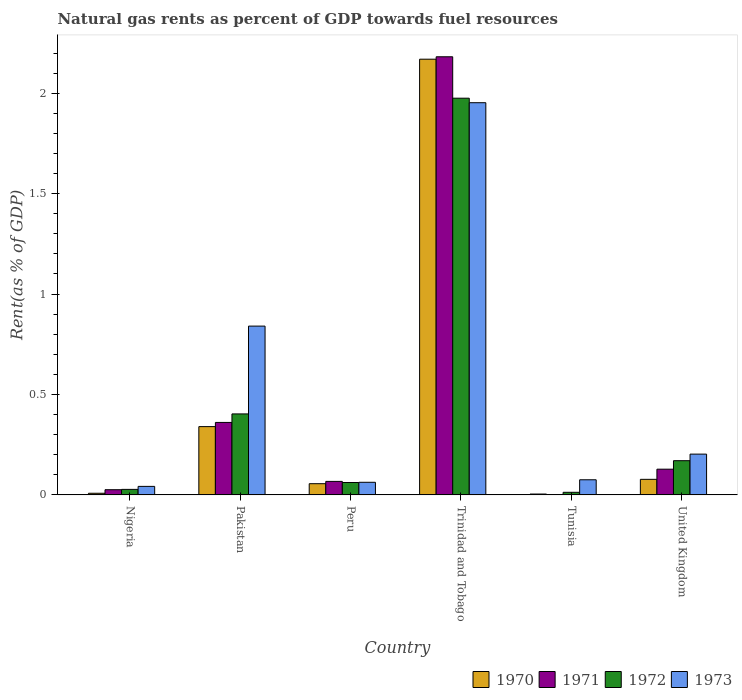How many different coloured bars are there?
Offer a terse response. 4. How many groups of bars are there?
Offer a terse response. 6. Are the number of bars on each tick of the X-axis equal?
Your answer should be very brief. Yes. How many bars are there on the 3rd tick from the right?
Provide a succinct answer. 4. What is the label of the 4th group of bars from the left?
Your answer should be very brief. Trinidad and Tobago. What is the matural gas rent in 1972 in United Kingdom?
Offer a very short reply. 0.17. Across all countries, what is the maximum matural gas rent in 1971?
Offer a terse response. 2.18. Across all countries, what is the minimum matural gas rent in 1971?
Offer a terse response. 0. In which country was the matural gas rent in 1973 maximum?
Offer a terse response. Trinidad and Tobago. In which country was the matural gas rent in 1972 minimum?
Provide a short and direct response. Tunisia. What is the total matural gas rent in 1972 in the graph?
Keep it short and to the point. 2.65. What is the difference between the matural gas rent in 1973 in Nigeria and that in Pakistan?
Your response must be concise. -0.8. What is the difference between the matural gas rent in 1970 in Tunisia and the matural gas rent in 1972 in Pakistan?
Offer a terse response. -0.4. What is the average matural gas rent in 1972 per country?
Your answer should be compact. 0.44. What is the difference between the matural gas rent of/in 1973 and matural gas rent of/in 1970 in Trinidad and Tobago?
Provide a short and direct response. -0.22. In how many countries, is the matural gas rent in 1970 greater than 2 %?
Provide a succinct answer. 1. What is the ratio of the matural gas rent in 1971 in Nigeria to that in Trinidad and Tobago?
Make the answer very short. 0.01. What is the difference between the highest and the second highest matural gas rent in 1971?
Offer a terse response. -1.82. What is the difference between the highest and the lowest matural gas rent in 1973?
Provide a succinct answer. 1.91. Is the sum of the matural gas rent in 1973 in Trinidad and Tobago and Tunisia greater than the maximum matural gas rent in 1971 across all countries?
Offer a terse response. No. Is it the case that in every country, the sum of the matural gas rent in 1971 and matural gas rent in 1973 is greater than the sum of matural gas rent in 1970 and matural gas rent in 1972?
Your response must be concise. No. What does the 2nd bar from the left in Peru represents?
Your answer should be very brief. 1971. Is it the case that in every country, the sum of the matural gas rent in 1971 and matural gas rent in 1973 is greater than the matural gas rent in 1972?
Offer a terse response. Yes. How many bars are there?
Offer a very short reply. 24. How many countries are there in the graph?
Make the answer very short. 6. Are the values on the major ticks of Y-axis written in scientific E-notation?
Your answer should be compact. No. Does the graph contain any zero values?
Provide a succinct answer. No. Does the graph contain grids?
Provide a succinct answer. No. Where does the legend appear in the graph?
Make the answer very short. Bottom right. How many legend labels are there?
Offer a terse response. 4. What is the title of the graph?
Provide a succinct answer. Natural gas rents as percent of GDP towards fuel resources. What is the label or title of the Y-axis?
Your answer should be very brief. Rent(as % of GDP). What is the Rent(as % of GDP) of 1970 in Nigeria?
Offer a terse response. 0.01. What is the Rent(as % of GDP) of 1971 in Nigeria?
Offer a terse response. 0.03. What is the Rent(as % of GDP) in 1972 in Nigeria?
Your answer should be compact. 0.03. What is the Rent(as % of GDP) in 1973 in Nigeria?
Offer a very short reply. 0.04. What is the Rent(as % of GDP) of 1970 in Pakistan?
Provide a succinct answer. 0.34. What is the Rent(as % of GDP) in 1971 in Pakistan?
Offer a very short reply. 0.36. What is the Rent(as % of GDP) in 1972 in Pakistan?
Your response must be concise. 0.4. What is the Rent(as % of GDP) in 1973 in Pakistan?
Provide a succinct answer. 0.84. What is the Rent(as % of GDP) of 1970 in Peru?
Offer a terse response. 0.06. What is the Rent(as % of GDP) of 1971 in Peru?
Offer a terse response. 0.07. What is the Rent(as % of GDP) in 1972 in Peru?
Your answer should be compact. 0.06. What is the Rent(as % of GDP) of 1973 in Peru?
Ensure brevity in your answer.  0.06. What is the Rent(as % of GDP) in 1970 in Trinidad and Tobago?
Offer a very short reply. 2.17. What is the Rent(as % of GDP) in 1971 in Trinidad and Tobago?
Make the answer very short. 2.18. What is the Rent(as % of GDP) of 1972 in Trinidad and Tobago?
Your answer should be compact. 1.98. What is the Rent(as % of GDP) in 1973 in Trinidad and Tobago?
Offer a terse response. 1.95. What is the Rent(as % of GDP) of 1970 in Tunisia?
Offer a very short reply. 0. What is the Rent(as % of GDP) in 1971 in Tunisia?
Your response must be concise. 0. What is the Rent(as % of GDP) of 1972 in Tunisia?
Keep it short and to the point. 0.01. What is the Rent(as % of GDP) in 1973 in Tunisia?
Ensure brevity in your answer.  0.08. What is the Rent(as % of GDP) in 1970 in United Kingdom?
Offer a very short reply. 0.08. What is the Rent(as % of GDP) in 1971 in United Kingdom?
Ensure brevity in your answer.  0.13. What is the Rent(as % of GDP) in 1972 in United Kingdom?
Offer a terse response. 0.17. What is the Rent(as % of GDP) in 1973 in United Kingdom?
Provide a succinct answer. 0.2. Across all countries, what is the maximum Rent(as % of GDP) of 1970?
Make the answer very short. 2.17. Across all countries, what is the maximum Rent(as % of GDP) in 1971?
Offer a terse response. 2.18. Across all countries, what is the maximum Rent(as % of GDP) in 1972?
Provide a short and direct response. 1.98. Across all countries, what is the maximum Rent(as % of GDP) of 1973?
Give a very brief answer. 1.95. Across all countries, what is the minimum Rent(as % of GDP) of 1970?
Provide a short and direct response. 0. Across all countries, what is the minimum Rent(as % of GDP) of 1971?
Your answer should be compact. 0. Across all countries, what is the minimum Rent(as % of GDP) in 1972?
Offer a terse response. 0.01. Across all countries, what is the minimum Rent(as % of GDP) of 1973?
Provide a short and direct response. 0.04. What is the total Rent(as % of GDP) in 1970 in the graph?
Your answer should be very brief. 2.65. What is the total Rent(as % of GDP) in 1971 in the graph?
Make the answer very short. 2.76. What is the total Rent(as % of GDP) in 1972 in the graph?
Your answer should be compact. 2.65. What is the total Rent(as % of GDP) in 1973 in the graph?
Make the answer very short. 3.18. What is the difference between the Rent(as % of GDP) in 1970 in Nigeria and that in Pakistan?
Your response must be concise. -0.33. What is the difference between the Rent(as % of GDP) of 1971 in Nigeria and that in Pakistan?
Offer a very short reply. -0.34. What is the difference between the Rent(as % of GDP) in 1972 in Nigeria and that in Pakistan?
Ensure brevity in your answer.  -0.38. What is the difference between the Rent(as % of GDP) in 1973 in Nigeria and that in Pakistan?
Your answer should be very brief. -0.8. What is the difference between the Rent(as % of GDP) in 1970 in Nigeria and that in Peru?
Provide a succinct answer. -0.05. What is the difference between the Rent(as % of GDP) of 1971 in Nigeria and that in Peru?
Ensure brevity in your answer.  -0.04. What is the difference between the Rent(as % of GDP) of 1972 in Nigeria and that in Peru?
Provide a succinct answer. -0.03. What is the difference between the Rent(as % of GDP) in 1973 in Nigeria and that in Peru?
Your answer should be compact. -0.02. What is the difference between the Rent(as % of GDP) of 1970 in Nigeria and that in Trinidad and Tobago?
Your answer should be very brief. -2.16. What is the difference between the Rent(as % of GDP) in 1971 in Nigeria and that in Trinidad and Tobago?
Ensure brevity in your answer.  -2.16. What is the difference between the Rent(as % of GDP) of 1972 in Nigeria and that in Trinidad and Tobago?
Offer a terse response. -1.95. What is the difference between the Rent(as % of GDP) of 1973 in Nigeria and that in Trinidad and Tobago?
Provide a short and direct response. -1.91. What is the difference between the Rent(as % of GDP) of 1970 in Nigeria and that in Tunisia?
Give a very brief answer. 0. What is the difference between the Rent(as % of GDP) in 1971 in Nigeria and that in Tunisia?
Ensure brevity in your answer.  0.03. What is the difference between the Rent(as % of GDP) in 1972 in Nigeria and that in Tunisia?
Offer a very short reply. 0.01. What is the difference between the Rent(as % of GDP) in 1973 in Nigeria and that in Tunisia?
Give a very brief answer. -0.03. What is the difference between the Rent(as % of GDP) in 1970 in Nigeria and that in United Kingdom?
Your answer should be very brief. -0.07. What is the difference between the Rent(as % of GDP) of 1971 in Nigeria and that in United Kingdom?
Your answer should be compact. -0.1. What is the difference between the Rent(as % of GDP) of 1972 in Nigeria and that in United Kingdom?
Give a very brief answer. -0.14. What is the difference between the Rent(as % of GDP) of 1973 in Nigeria and that in United Kingdom?
Provide a short and direct response. -0.16. What is the difference between the Rent(as % of GDP) of 1970 in Pakistan and that in Peru?
Give a very brief answer. 0.28. What is the difference between the Rent(as % of GDP) in 1971 in Pakistan and that in Peru?
Ensure brevity in your answer.  0.29. What is the difference between the Rent(as % of GDP) of 1972 in Pakistan and that in Peru?
Provide a short and direct response. 0.34. What is the difference between the Rent(as % of GDP) of 1973 in Pakistan and that in Peru?
Ensure brevity in your answer.  0.78. What is the difference between the Rent(as % of GDP) in 1970 in Pakistan and that in Trinidad and Tobago?
Your answer should be very brief. -1.83. What is the difference between the Rent(as % of GDP) in 1971 in Pakistan and that in Trinidad and Tobago?
Give a very brief answer. -1.82. What is the difference between the Rent(as % of GDP) in 1972 in Pakistan and that in Trinidad and Tobago?
Make the answer very short. -1.57. What is the difference between the Rent(as % of GDP) of 1973 in Pakistan and that in Trinidad and Tobago?
Your response must be concise. -1.11. What is the difference between the Rent(as % of GDP) of 1970 in Pakistan and that in Tunisia?
Offer a terse response. 0.34. What is the difference between the Rent(as % of GDP) of 1971 in Pakistan and that in Tunisia?
Provide a succinct answer. 0.36. What is the difference between the Rent(as % of GDP) of 1972 in Pakistan and that in Tunisia?
Offer a very short reply. 0.39. What is the difference between the Rent(as % of GDP) of 1973 in Pakistan and that in Tunisia?
Ensure brevity in your answer.  0.77. What is the difference between the Rent(as % of GDP) in 1970 in Pakistan and that in United Kingdom?
Ensure brevity in your answer.  0.26. What is the difference between the Rent(as % of GDP) of 1971 in Pakistan and that in United Kingdom?
Make the answer very short. 0.23. What is the difference between the Rent(as % of GDP) in 1972 in Pakistan and that in United Kingdom?
Your answer should be compact. 0.23. What is the difference between the Rent(as % of GDP) of 1973 in Pakistan and that in United Kingdom?
Provide a short and direct response. 0.64. What is the difference between the Rent(as % of GDP) of 1970 in Peru and that in Trinidad and Tobago?
Keep it short and to the point. -2.11. What is the difference between the Rent(as % of GDP) in 1971 in Peru and that in Trinidad and Tobago?
Your answer should be very brief. -2.11. What is the difference between the Rent(as % of GDP) in 1972 in Peru and that in Trinidad and Tobago?
Provide a succinct answer. -1.91. What is the difference between the Rent(as % of GDP) of 1973 in Peru and that in Trinidad and Tobago?
Give a very brief answer. -1.89. What is the difference between the Rent(as % of GDP) in 1970 in Peru and that in Tunisia?
Offer a terse response. 0.05. What is the difference between the Rent(as % of GDP) in 1971 in Peru and that in Tunisia?
Your answer should be compact. 0.07. What is the difference between the Rent(as % of GDP) in 1972 in Peru and that in Tunisia?
Keep it short and to the point. 0.05. What is the difference between the Rent(as % of GDP) of 1973 in Peru and that in Tunisia?
Your answer should be compact. -0.01. What is the difference between the Rent(as % of GDP) in 1970 in Peru and that in United Kingdom?
Provide a succinct answer. -0.02. What is the difference between the Rent(as % of GDP) of 1971 in Peru and that in United Kingdom?
Your response must be concise. -0.06. What is the difference between the Rent(as % of GDP) of 1972 in Peru and that in United Kingdom?
Give a very brief answer. -0.11. What is the difference between the Rent(as % of GDP) in 1973 in Peru and that in United Kingdom?
Provide a short and direct response. -0.14. What is the difference between the Rent(as % of GDP) of 1970 in Trinidad and Tobago and that in Tunisia?
Provide a short and direct response. 2.17. What is the difference between the Rent(as % of GDP) in 1971 in Trinidad and Tobago and that in Tunisia?
Ensure brevity in your answer.  2.18. What is the difference between the Rent(as % of GDP) in 1972 in Trinidad and Tobago and that in Tunisia?
Give a very brief answer. 1.96. What is the difference between the Rent(as % of GDP) in 1973 in Trinidad and Tobago and that in Tunisia?
Ensure brevity in your answer.  1.88. What is the difference between the Rent(as % of GDP) in 1970 in Trinidad and Tobago and that in United Kingdom?
Make the answer very short. 2.09. What is the difference between the Rent(as % of GDP) in 1971 in Trinidad and Tobago and that in United Kingdom?
Give a very brief answer. 2.05. What is the difference between the Rent(as % of GDP) in 1972 in Trinidad and Tobago and that in United Kingdom?
Your answer should be compact. 1.8. What is the difference between the Rent(as % of GDP) of 1973 in Trinidad and Tobago and that in United Kingdom?
Your answer should be compact. 1.75. What is the difference between the Rent(as % of GDP) of 1970 in Tunisia and that in United Kingdom?
Your answer should be very brief. -0.07. What is the difference between the Rent(as % of GDP) of 1971 in Tunisia and that in United Kingdom?
Your answer should be very brief. -0.13. What is the difference between the Rent(as % of GDP) of 1972 in Tunisia and that in United Kingdom?
Provide a succinct answer. -0.16. What is the difference between the Rent(as % of GDP) in 1973 in Tunisia and that in United Kingdom?
Provide a short and direct response. -0.13. What is the difference between the Rent(as % of GDP) in 1970 in Nigeria and the Rent(as % of GDP) in 1971 in Pakistan?
Offer a very short reply. -0.35. What is the difference between the Rent(as % of GDP) of 1970 in Nigeria and the Rent(as % of GDP) of 1972 in Pakistan?
Make the answer very short. -0.4. What is the difference between the Rent(as % of GDP) in 1970 in Nigeria and the Rent(as % of GDP) in 1973 in Pakistan?
Offer a very short reply. -0.83. What is the difference between the Rent(as % of GDP) of 1971 in Nigeria and the Rent(as % of GDP) of 1972 in Pakistan?
Keep it short and to the point. -0.38. What is the difference between the Rent(as % of GDP) in 1971 in Nigeria and the Rent(as % of GDP) in 1973 in Pakistan?
Ensure brevity in your answer.  -0.81. What is the difference between the Rent(as % of GDP) of 1972 in Nigeria and the Rent(as % of GDP) of 1973 in Pakistan?
Your answer should be compact. -0.81. What is the difference between the Rent(as % of GDP) of 1970 in Nigeria and the Rent(as % of GDP) of 1971 in Peru?
Offer a very short reply. -0.06. What is the difference between the Rent(as % of GDP) of 1970 in Nigeria and the Rent(as % of GDP) of 1972 in Peru?
Give a very brief answer. -0.05. What is the difference between the Rent(as % of GDP) of 1970 in Nigeria and the Rent(as % of GDP) of 1973 in Peru?
Provide a short and direct response. -0.05. What is the difference between the Rent(as % of GDP) in 1971 in Nigeria and the Rent(as % of GDP) in 1972 in Peru?
Provide a short and direct response. -0.04. What is the difference between the Rent(as % of GDP) of 1971 in Nigeria and the Rent(as % of GDP) of 1973 in Peru?
Keep it short and to the point. -0.04. What is the difference between the Rent(as % of GDP) in 1972 in Nigeria and the Rent(as % of GDP) in 1973 in Peru?
Provide a succinct answer. -0.04. What is the difference between the Rent(as % of GDP) of 1970 in Nigeria and the Rent(as % of GDP) of 1971 in Trinidad and Tobago?
Give a very brief answer. -2.17. What is the difference between the Rent(as % of GDP) in 1970 in Nigeria and the Rent(as % of GDP) in 1972 in Trinidad and Tobago?
Offer a terse response. -1.97. What is the difference between the Rent(as % of GDP) in 1970 in Nigeria and the Rent(as % of GDP) in 1973 in Trinidad and Tobago?
Provide a succinct answer. -1.94. What is the difference between the Rent(as % of GDP) of 1971 in Nigeria and the Rent(as % of GDP) of 1972 in Trinidad and Tobago?
Make the answer very short. -1.95. What is the difference between the Rent(as % of GDP) of 1971 in Nigeria and the Rent(as % of GDP) of 1973 in Trinidad and Tobago?
Keep it short and to the point. -1.93. What is the difference between the Rent(as % of GDP) of 1972 in Nigeria and the Rent(as % of GDP) of 1973 in Trinidad and Tobago?
Keep it short and to the point. -1.93. What is the difference between the Rent(as % of GDP) of 1970 in Nigeria and the Rent(as % of GDP) of 1971 in Tunisia?
Provide a short and direct response. 0.01. What is the difference between the Rent(as % of GDP) of 1970 in Nigeria and the Rent(as % of GDP) of 1972 in Tunisia?
Your response must be concise. -0. What is the difference between the Rent(as % of GDP) in 1970 in Nigeria and the Rent(as % of GDP) in 1973 in Tunisia?
Your answer should be very brief. -0.07. What is the difference between the Rent(as % of GDP) of 1971 in Nigeria and the Rent(as % of GDP) of 1972 in Tunisia?
Provide a succinct answer. 0.01. What is the difference between the Rent(as % of GDP) in 1971 in Nigeria and the Rent(as % of GDP) in 1973 in Tunisia?
Offer a very short reply. -0.05. What is the difference between the Rent(as % of GDP) of 1972 in Nigeria and the Rent(as % of GDP) of 1973 in Tunisia?
Provide a short and direct response. -0.05. What is the difference between the Rent(as % of GDP) in 1970 in Nigeria and the Rent(as % of GDP) in 1971 in United Kingdom?
Provide a succinct answer. -0.12. What is the difference between the Rent(as % of GDP) in 1970 in Nigeria and the Rent(as % of GDP) in 1972 in United Kingdom?
Give a very brief answer. -0.16. What is the difference between the Rent(as % of GDP) in 1970 in Nigeria and the Rent(as % of GDP) in 1973 in United Kingdom?
Your response must be concise. -0.19. What is the difference between the Rent(as % of GDP) of 1971 in Nigeria and the Rent(as % of GDP) of 1972 in United Kingdom?
Make the answer very short. -0.14. What is the difference between the Rent(as % of GDP) of 1971 in Nigeria and the Rent(as % of GDP) of 1973 in United Kingdom?
Offer a terse response. -0.18. What is the difference between the Rent(as % of GDP) in 1972 in Nigeria and the Rent(as % of GDP) in 1973 in United Kingdom?
Offer a terse response. -0.18. What is the difference between the Rent(as % of GDP) of 1970 in Pakistan and the Rent(as % of GDP) of 1971 in Peru?
Offer a terse response. 0.27. What is the difference between the Rent(as % of GDP) in 1970 in Pakistan and the Rent(as % of GDP) in 1972 in Peru?
Make the answer very short. 0.28. What is the difference between the Rent(as % of GDP) in 1970 in Pakistan and the Rent(as % of GDP) in 1973 in Peru?
Offer a terse response. 0.28. What is the difference between the Rent(as % of GDP) of 1971 in Pakistan and the Rent(as % of GDP) of 1972 in Peru?
Give a very brief answer. 0.3. What is the difference between the Rent(as % of GDP) in 1971 in Pakistan and the Rent(as % of GDP) in 1973 in Peru?
Provide a succinct answer. 0.3. What is the difference between the Rent(as % of GDP) in 1972 in Pakistan and the Rent(as % of GDP) in 1973 in Peru?
Offer a very short reply. 0.34. What is the difference between the Rent(as % of GDP) of 1970 in Pakistan and the Rent(as % of GDP) of 1971 in Trinidad and Tobago?
Keep it short and to the point. -1.84. What is the difference between the Rent(as % of GDP) in 1970 in Pakistan and the Rent(as % of GDP) in 1972 in Trinidad and Tobago?
Offer a terse response. -1.64. What is the difference between the Rent(as % of GDP) in 1970 in Pakistan and the Rent(as % of GDP) in 1973 in Trinidad and Tobago?
Your answer should be very brief. -1.61. What is the difference between the Rent(as % of GDP) in 1971 in Pakistan and the Rent(as % of GDP) in 1972 in Trinidad and Tobago?
Make the answer very short. -1.61. What is the difference between the Rent(as % of GDP) in 1971 in Pakistan and the Rent(as % of GDP) in 1973 in Trinidad and Tobago?
Your answer should be very brief. -1.59. What is the difference between the Rent(as % of GDP) in 1972 in Pakistan and the Rent(as % of GDP) in 1973 in Trinidad and Tobago?
Your response must be concise. -1.55. What is the difference between the Rent(as % of GDP) in 1970 in Pakistan and the Rent(as % of GDP) in 1971 in Tunisia?
Make the answer very short. 0.34. What is the difference between the Rent(as % of GDP) of 1970 in Pakistan and the Rent(as % of GDP) of 1972 in Tunisia?
Your response must be concise. 0.33. What is the difference between the Rent(as % of GDP) in 1970 in Pakistan and the Rent(as % of GDP) in 1973 in Tunisia?
Make the answer very short. 0.26. What is the difference between the Rent(as % of GDP) of 1971 in Pakistan and the Rent(as % of GDP) of 1972 in Tunisia?
Make the answer very short. 0.35. What is the difference between the Rent(as % of GDP) in 1971 in Pakistan and the Rent(as % of GDP) in 1973 in Tunisia?
Your response must be concise. 0.29. What is the difference between the Rent(as % of GDP) of 1972 in Pakistan and the Rent(as % of GDP) of 1973 in Tunisia?
Offer a very short reply. 0.33. What is the difference between the Rent(as % of GDP) in 1970 in Pakistan and the Rent(as % of GDP) in 1971 in United Kingdom?
Make the answer very short. 0.21. What is the difference between the Rent(as % of GDP) of 1970 in Pakistan and the Rent(as % of GDP) of 1972 in United Kingdom?
Provide a short and direct response. 0.17. What is the difference between the Rent(as % of GDP) of 1970 in Pakistan and the Rent(as % of GDP) of 1973 in United Kingdom?
Make the answer very short. 0.14. What is the difference between the Rent(as % of GDP) of 1971 in Pakistan and the Rent(as % of GDP) of 1972 in United Kingdom?
Give a very brief answer. 0.19. What is the difference between the Rent(as % of GDP) in 1971 in Pakistan and the Rent(as % of GDP) in 1973 in United Kingdom?
Offer a terse response. 0.16. What is the difference between the Rent(as % of GDP) in 1972 in Pakistan and the Rent(as % of GDP) in 1973 in United Kingdom?
Offer a very short reply. 0.2. What is the difference between the Rent(as % of GDP) of 1970 in Peru and the Rent(as % of GDP) of 1971 in Trinidad and Tobago?
Ensure brevity in your answer.  -2.13. What is the difference between the Rent(as % of GDP) of 1970 in Peru and the Rent(as % of GDP) of 1972 in Trinidad and Tobago?
Provide a succinct answer. -1.92. What is the difference between the Rent(as % of GDP) in 1970 in Peru and the Rent(as % of GDP) in 1973 in Trinidad and Tobago?
Your answer should be compact. -1.9. What is the difference between the Rent(as % of GDP) of 1971 in Peru and the Rent(as % of GDP) of 1972 in Trinidad and Tobago?
Keep it short and to the point. -1.91. What is the difference between the Rent(as % of GDP) of 1971 in Peru and the Rent(as % of GDP) of 1973 in Trinidad and Tobago?
Give a very brief answer. -1.89. What is the difference between the Rent(as % of GDP) in 1972 in Peru and the Rent(as % of GDP) in 1973 in Trinidad and Tobago?
Make the answer very short. -1.89. What is the difference between the Rent(as % of GDP) of 1970 in Peru and the Rent(as % of GDP) of 1971 in Tunisia?
Provide a succinct answer. 0.06. What is the difference between the Rent(as % of GDP) in 1970 in Peru and the Rent(as % of GDP) in 1972 in Tunisia?
Offer a very short reply. 0.04. What is the difference between the Rent(as % of GDP) in 1970 in Peru and the Rent(as % of GDP) in 1973 in Tunisia?
Your response must be concise. -0.02. What is the difference between the Rent(as % of GDP) of 1971 in Peru and the Rent(as % of GDP) of 1972 in Tunisia?
Make the answer very short. 0.05. What is the difference between the Rent(as % of GDP) of 1971 in Peru and the Rent(as % of GDP) of 1973 in Tunisia?
Provide a succinct answer. -0.01. What is the difference between the Rent(as % of GDP) in 1972 in Peru and the Rent(as % of GDP) in 1973 in Tunisia?
Your answer should be very brief. -0.01. What is the difference between the Rent(as % of GDP) of 1970 in Peru and the Rent(as % of GDP) of 1971 in United Kingdom?
Keep it short and to the point. -0.07. What is the difference between the Rent(as % of GDP) of 1970 in Peru and the Rent(as % of GDP) of 1972 in United Kingdom?
Ensure brevity in your answer.  -0.11. What is the difference between the Rent(as % of GDP) in 1970 in Peru and the Rent(as % of GDP) in 1973 in United Kingdom?
Ensure brevity in your answer.  -0.15. What is the difference between the Rent(as % of GDP) of 1971 in Peru and the Rent(as % of GDP) of 1972 in United Kingdom?
Provide a short and direct response. -0.1. What is the difference between the Rent(as % of GDP) of 1971 in Peru and the Rent(as % of GDP) of 1973 in United Kingdom?
Give a very brief answer. -0.14. What is the difference between the Rent(as % of GDP) of 1972 in Peru and the Rent(as % of GDP) of 1973 in United Kingdom?
Give a very brief answer. -0.14. What is the difference between the Rent(as % of GDP) of 1970 in Trinidad and Tobago and the Rent(as % of GDP) of 1971 in Tunisia?
Your response must be concise. 2.17. What is the difference between the Rent(as % of GDP) in 1970 in Trinidad and Tobago and the Rent(as % of GDP) in 1972 in Tunisia?
Your answer should be very brief. 2.16. What is the difference between the Rent(as % of GDP) in 1970 in Trinidad and Tobago and the Rent(as % of GDP) in 1973 in Tunisia?
Provide a short and direct response. 2.09. What is the difference between the Rent(as % of GDP) of 1971 in Trinidad and Tobago and the Rent(as % of GDP) of 1972 in Tunisia?
Your response must be concise. 2.17. What is the difference between the Rent(as % of GDP) in 1971 in Trinidad and Tobago and the Rent(as % of GDP) in 1973 in Tunisia?
Make the answer very short. 2.11. What is the difference between the Rent(as % of GDP) of 1972 in Trinidad and Tobago and the Rent(as % of GDP) of 1973 in Tunisia?
Provide a succinct answer. 1.9. What is the difference between the Rent(as % of GDP) of 1970 in Trinidad and Tobago and the Rent(as % of GDP) of 1971 in United Kingdom?
Your answer should be compact. 2.04. What is the difference between the Rent(as % of GDP) in 1970 in Trinidad and Tobago and the Rent(as % of GDP) in 1972 in United Kingdom?
Provide a succinct answer. 2. What is the difference between the Rent(as % of GDP) in 1970 in Trinidad and Tobago and the Rent(as % of GDP) in 1973 in United Kingdom?
Your answer should be very brief. 1.97. What is the difference between the Rent(as % of GDP) in 1971 in Trinidad and Tobago and the Rent(as % of GDP) in 1972 in United Kingdom?
Offer a very short reply. 2.01. What is the difference between the Rent(as % of GDP) of 1971 in Trinidad and Tobago and the Rent(as % of GDP) of 1973 in United Kingdom?
Give a very brief answer. 1.98. What is the difference between the Rent(as % of GDP) of 1972 in Trinidad and Tobago and the Rent(as % of GDP) of 1973 in United Kingdom?
Your answer should be very brief. 1.77. What is the difference between the Rent(as % of GDP) in 1970 in Tunisia and the Rent(as % of GDP) in 1971 in United Kingdom?
Your response must be concise. -0.12. What is the difference between the Rent(as % of GDP) in 1970 in Tunisia and the Rent(as % of GDP) in 1972 in United Kingdom?
Provide a short and direct response. -0.17. What is the difference between the Rent(as % of GDP) in 1970 in Tunisia and the Rent(as % of GDP) in 1973 in United Kingdom?
Your answer should be very brief. -0.2. What is the difference between the Rent(as % of GDP) of 1971 in Tunisia and the Rent(as % of GDP) of 1972 in United Kingdom?
Offer a very short reply. -0.17. What is the difference between the Rent(as % of GDP) in 1971 in Tunisia and the Rent(as % of GDP) in 1973 in United Kingdom?
Offer a very short reply. -0.2. What is the difference between the Rent(as % of GDP) of 1972 in Tunisia and the Rent(as % of GDP) of 1973 in United Kingdom?
Offer a terse response. -0.19. What is the average Rent(as % of GDP) in 1970 per country?
Provide a succinct answer. 0.44. What is the average Rent(as % of GDP) of 1971 per country?
Ensure brevity in your answer.  0.46. What is the average Rent(as % of GDP) of 1972 per country?
Keep it short and to the point. 0.44. What is the average Rent(as % of GDP) in 1973 per country?
Make the answer very short. 0.53. What is the difference between the Rent(as % of GDP) in 1970 and Rent(as % of GDP) in 1971 in Nigeria?
Provide a succinct answer. -0.02. What is the difference between the Rent(as % of GDP) of 1970 and Rent(as % of GDP) of 1972 in Nigeria?
Offer a very short reply. -0.02. What is the difference between the Rent(as % of GDP) in 1970 and Rent(as % of GDP) in 1973 in Nigeria?
Give a very brief answer. -0.03. What is the difference between the Rent(as % of GDP) in 1971 and Rent(as % of GDP) in 1972 in Nigeria?
Your answer should be compact. -0. What is the difference between the Rent(as % of GDP) of 1971 and Rent(as % of GDP) of 1973 in Nigeria?
Ensure brevity in your answer.  -0.02. What is the difference between the Rent(as % of GDP) of 1972 and Rent(as % of GDP) of 1973 in Nigeria?
Ensure brevity in your answer.  -0.01. What is the difference between the Rent(as % of GDP) of 1970 and Rent(as % of GDP) of 1971 in Pakistan?
Ensure brevity in your answer.  -0.02. What is the difference between the Rent(as % of GDP) of 1970 and Rent(as % of GDP) of 1972 in Pakistan?
Your answer should be very brief. -0.06. What is the difference between the Rent(as % of GDP) in 1970 and Rent(as % of GDP) in 1973 in Pakistan?
Offer a very short reply. -0.5. What is the difference between the Rent(as % of GDP) in 1971 and Rent(as % of GDP) in 1972 in Pakistan?
Your answer should be very brief. -0.04. What is the difference between the Rent(as % of GDP) in 1971 and Rent(as % of GDP) in 1973 in Pakistan?
Your answer should be compact. -0.48. What is the difference between the Rent(as % of GDP) in 1972 and Rent(as % of GDP) in 1973 in Pakistan?
Offer a terse response. -0.44. What is the difference between the Rent(as % of GDP) in 1970 and Rent(as % of GDP) in 1971 in Peru?
Your answer should be very brief. -0.01. What is the difference between the Rent(as % of GDP) in 1970 and Rent(as % of GDP) in 1972 in Peru?
Offer a terse response. -0.01. What is the difference between the Rent(as % of GDP) in 1970 and Rent(as % of GDP) in 1973 in Peru?
Offer a very short reply. -0.01. What is the difference between the Rent(as % of GDP) of 1971 and Rent(as % of GDP) of 1972 in Peru?
Provide a short and direct response. 0.01. What is the difference between the Rent(as % of GDP) in 1971 and Rent(as % of GDP) in 1973 in Peru?
Offer a terse response. 0. What is the difference between the Rent(as % of GDP) of 1972 and Rent(as % of GDP) of 1973 in Peru?
Your answer should be compact. -0. What is the difference between the Rent(as % of GDP) in 1970 and Rent(as % of GDP) in 1971 in Trinidad and Tobago?
Provide a short and direct response. -0.01. What is the difference between the Rent(as % of GDP) in 1970 and Rent(as % of GDP) in 1972 in Trinidad and Tobago?
Your answer should be very brief. 0.19. What is the difference between the Rent(as % of GDP) in 1970 and Rent(as % of GDP) in 1973 in Trinidad and Tobago?
Provide a short and direct response. 0.22. What is the difference between the Rent(as % of GDP) in 1971 and Rent(as % of GDP) in 1972 in Trinidad and Tobago?
Offer a very short reply. 0.21. What is the difference between the Rent(as % of GDP) of 1971 and Rent(as % of GDP) of 1973 in Trinidad and Tobago?
Your answer should be very brief. 0.23. What is the difference between the Rent(as % of GDP) of 1972 and Rent(as % of GDP) of 1973 in Trinidad and Tobago?
Offer a terse response. 0.02. What is the difference between the Rent(as % of GDP) of 1970 and Rent(as % of GDP) of 1971 in Tunisia?
Give a very brief answer. 0. What is the difference between the Rent(as % of GDP) of 1970 and Rent(as % of GDP) of 1972 in Tunisia?
Offer a terse response. -0.01. What is the difference between the Rent(as % of GDP) of 1970 and Rent(as % of GDP) of 1973 in Tunisia?
Offer a very short reply. -0.07. What is the difference between the Rent(as % of GDP) in 1971 and Rent(as % of GDP) in 1972 in Tunisia?
Keep it short and to the point. -0.01. What is the difference between the Rent(as % of GDP) of 1971 and Rent(as % of GDP) of 1973 in Tunisia?
Your answer should be compact. -0.07. What is the difference between the Rent(as % of GDP) of 1972 and Rent(as % of GDP) of 1973 in Tunisia?
Make the answer very short. -0.06. What is the difference between the Rent(as % of GDP) of 1970 and Rent(as % of GDP) of 1971 in United Kingdom?
Your response must be concise. -0.05. What is the difference between the Rent(as % of GDP) of 1970 and Rent(as % of GDP) of 1972 in United Kingdom?
Give a very brief answer. -0.09. What is the difference between the Rent(as % of GDP) of 1970 and Rent(as % of GDP) of 1973 in United Kingdom?
Give a very brief answer. -0.13. What is the difference between the Rent(as % of GDP) in 1971 and Rent(as % of GDP) in 1972 in United Kingdom?
Your answer should be very brief. -0.04. What is the difference between the Rent(as % of GDP) of 1971 and Rent(as % of GDP) of 1973 in United Kingdom?
Make the answer very short. -0.07. What is the difference between the Rent(as % of GDP) of 1972 and Rent(as % of GDP) of 1973 in United Kingdom?
Ensure brevity in your answer.  -0.03. What is the ratio of the Rent(as % of GDP) in 1970 in Nigeria to that in Pakistan?
Ensure brevity in your answer.  0.02. What is the ratio of the Rent(as % of GDP) in 1971 in Nigeria to that in Pakistan?
Offer a terse response. 0.07. What is the ratio of the Rent(as % of GDP) in 1972 in Nigeria to that in Pakistan?
Keep it short and to the point. 0.07. What is the ratio of the Rent(as % of GDP) in 1973 in Nigeria to that in Pakistan?
Ensure brevity in your answer.  0.05. What is the ratio of the Rent(as % of GDP) of 1970 in Nigeria to that in Peru?
Make the answer very short. 0.15. What is the ratio of the Rent(as % of GDP) of 1971 in Nigeria to that in Peru?
Give a very brief answer. 0.38. What is the ratio of the Rent(as % of GDP) in 1972 in Nigeria to that in Peru?
Your answer should be very brief. 0.44. What is the ratio of the Rent(as % of GDP) of 1973 in Nigeria to that in Peru?
Provide a short and direct response. 0.67. What is the ratio of the Rent(as % of GDP) of 1970 in Nigeria to that in Trinidad and Tobago?
Keep it short and to the point. 0. What is the ratio of the Rent(as % of GDP) of 1971 in Nigeria to that in Trinidad and Tobago?
Make the answer very short. 0.01. What is the ratio of the Rent(as % of GDP) in 1972 in Nigeria to that in Trinidad and Tobago?
Offer a very short reply. 0.01. What is the ratio of the Rent(as % of GDP) in 1973 in Nigeria to that in Trinidad and Tobago?
Give a very brief answer. 0.02. What is the ratio of the Rent(as % of GDP) of 1970 in Nigeria to that in Tunisia?
Ensure brevity in your answer.  1.92. What is the ratio of the Rent(as % of GDP) in 1971 in Nigeria to that in Tunisia?
Offer a very short reply. 34.77. What is the ratio of the Rent(as % of GDP) in 1972 in Nigeria to that in Tunisia?
Provide a succinct answer. 2.13. What is the ratio of the Rent(as % of GDP) of 1973 in Nigeria to that in Tunisia?
Your response must be concise. 0.56. What is the ratio of the Rent(as % of GDP) in 1970 in Nigeria to that in United Kingdom?
Your answer should be very brief. 0.1. What is the ratio of the Rent(as % of GDP) of 1971 in Nigeria to that in United Kingdom?
Your answer should be very brief. 0.2. What is the ratio of the Rent(as % of GDP) of 1972 in Nigeria to that in United Kingdom?
Your answer should be very brief. 0.16. What is the ratio of the Rent(as % of GDP) of 1973 in Nigeria to that in United Kingdom?
Your answer should be compact. 0.21. What is the ratio of the Rent(as % of GDP) in 1970 in Pakistan to that in Peru?
Keep it short and to the point. 6.1. What is the ratio of the Rent(as % of GDP) in 1971 in Pakistan to that in Peru?
Offer a terse response. 5.37. What is the ratio of the Rent(as % of GDP) in 1972 in Pakistan to that in Peru?
Offer a terse response. 6.54. What is the ratio of the Rent(as % of GDP) of 1973 in Pakistan to that in Peru?
Your answer should be compact. 13.39. What is the ratio of the Rent(as % of GDP) of 1970 in Pakistan to that in Trinidad and Tobago?
Your answer should be compact. 0.16. What is the ratio of the Rent(as % of GDP) of 1971 in Pakistan to that in Trinidad and Tobago?
Provide a succinct answer. 0.17. What is the ratio of the Rent(as % of GDP) of 1972 in Pakistan to that in Trinidad and Tobago?
Provide a succinct answer. 0.2. What is the ratio of the Rent(as % of GDP) in 1973 in Pakistan to that in Trinidad and Tobago?
Make the answer very short. 0.43. What is the ratio of the Rent(as % of GDP) in 1970 in Pakistan to that in Tunisia?
Your answer should be compact. 80.16. What is the ratio of the Rent(as % of GDP) of 1971 in Pakistan to that in Tunisia?
Your answer should be very brief. 486.4. What is the ratio of the Rent(as % of GDP) in 1972 in Pakistan to that in Tunisia?
Provide a short and direct response. 31.31. What is the ratio of the Rent(as % of GDP) in 1973 in Pakistan to that in Tunisia?
Your answer should be compact. 11.17. What is the ratio of the Rent(as % of GDP) in 1970 in Pakistan to that in United Kingdom?
Offer a very short reply. 4.39. What is the ratio of the Rent(as % of GDP) in 1971 in Pakistan to that in United Kingdom?
Ensure brevity in your answer.  2.82. What is the ratio of the Rent(as % of GDP) in 1972 in Pakistan to that in United Kingdom?
Your answer should be compact. 2.37. What is the ratio of the Rent(as % of GDP) in 1973 in Pakistan to that in United Kingdom?
Make the answer very short. 4.14. What is the ratio of the Rent(as % of GDP) of 1970 in Peru to that in Trinidad and Tobago?
Make the answer very short. 0.03. What is the ratio of the Rent(as % of GDP) in 1971 in Peru to that in Trinidad and Tobago?
Provide a succinct answer. 0.03. What is the ratio of the Rent(as % of GDP) of 1972 in Peru to that in Trinidad and Tobago?
Make the answer very short. 0.03. What is the ratio of the Rent(as % of GDP) of 1973 in Peru to that in Trinidad and Tobago?
Keep it short and to the point. 0.03. What is the ratio of the Rent(as % of GDP) of 1970 in Peru to that in Tunisia?
Your answer should be compact. 13.15. What is the ratio of the Rent(as % of GDP) in 1971 in Peru to that in Tunisia?
Give a very brief answer. 90.55. What is the ratio of the Rent(as % of GDP) of 1972 in Peru to that in Tunisia?
Provide a short and direct response. 4.79. What is the ratio of the Rent(as % of GDP) of 1973 in Peru to that in Tunisia?
Keep it short and to the point. 0.83. What is the ratio of the Rent(as % of GDP) of 1970 in Peru to that in United Kingdom?
Provide a short and direct response. 0.72. What is the ratio of the Rent(as % of GDP) in 1971 in Peru to that in United Kingdom?
Give a very brief answer. 0.52. What is the ratio of the Rent(as % of GDP) of 1972 in Peru to that in United Kingdom?
Your answer should be compact. 0.36. What is the ratio of the Rent(as % of GDP) in 1973 in Peru to that in United Kingdom?
Offer a very short reply. 0.31. What is the ratio of the Rent(as % of GDP) of 1970 in Trinidad and Tobago to that in Tunisia?
Your response must be concise. 511.49. What is the ratio of the Rent(as % of GDP) of 1971 in Trinidad and Tobago to that in Tunisia?
Offer a very short reply. 2940.6. What is the ratio of the Rent(as % of GDP) of 1972 in Trinidad and Tobago to that in Tunisia?
Your answer should be compact. 153.39. What is the ratio of the Rent(as % of GDP) in 1973 in Trinidad and Tobago to that in Tunisia?
Provide a succinct answer. 25.94. What is the ratio of the Rent(as % of GDP) in 1970 in Trinidad and Tobago to that in United Kingdom?
Make the answer very short. 27.99. What is the ratio of the Rent(as % of GDP) of 1971 in Trinidad and Tobago to that in United Kingdom?
Make the answer very short. 17.03. What is the ratio of the Rent(as % of GDP) in 1972 in Trinidad and Tobago to that in United Kingdom?
Ensure brevity in your answer.  11.6. What is the ratio of the Rent(as % of GDP) in 1973 in Trinidad and Tobago to that in United Kingdom?
Provide a short and direct response. 9.62. What is the ratio of the Rent(as % of GDP) in 1970 in Tunisia to that in United Kingdom?
Make the answer very short. 0.05. What is the ratio of the Rent(as % of GDP) of 1971 in Tunisia to that in United Kingdom?
Keep it short and to the point. 0.01. What is the ratio of the Rent(as % of GDP) of 1972 in Tunisia to that in United Kingdom?
Provide a succinct answer. 0.08. What is the ratio of the Rent(as % of GDP) in 1973 in Tunisia to that in United Kingdom?
Give a very brief answer. 0.37. What is the difference between the highest and the second highest Rent(as % of GDP) in 1970?
Offer a very short reply. 1.83. What is the difference between the highest and the second highest Rent(as % of GDP) of 1971?
Offer a terse response. 1.82. What is the difference between the highest and the second highest Rent(as % of GDP) of 1972?
Make the answer very short. 1.57. What is the difference between the highest and the second highest Rent(as % of GDP) of 1973?
Keep it short and to the point. 1.11. What is the difference between the highest and the lowest Rent(as % of GDP) of 1970?
Give a very brief answer. 2.17. What is the difference between the highest and the lowest Rent(as % of GDP) in 1971?
Offer a very short reply. 2.18. What is the difference between the highest and the lowest Rent(as % of GDP) of 1972?
Make the answer very short. 1.96. What is the difference between the highest and the lowest Rent(as % of GDP) of 1973?
Offer a terse response. 1.91. 